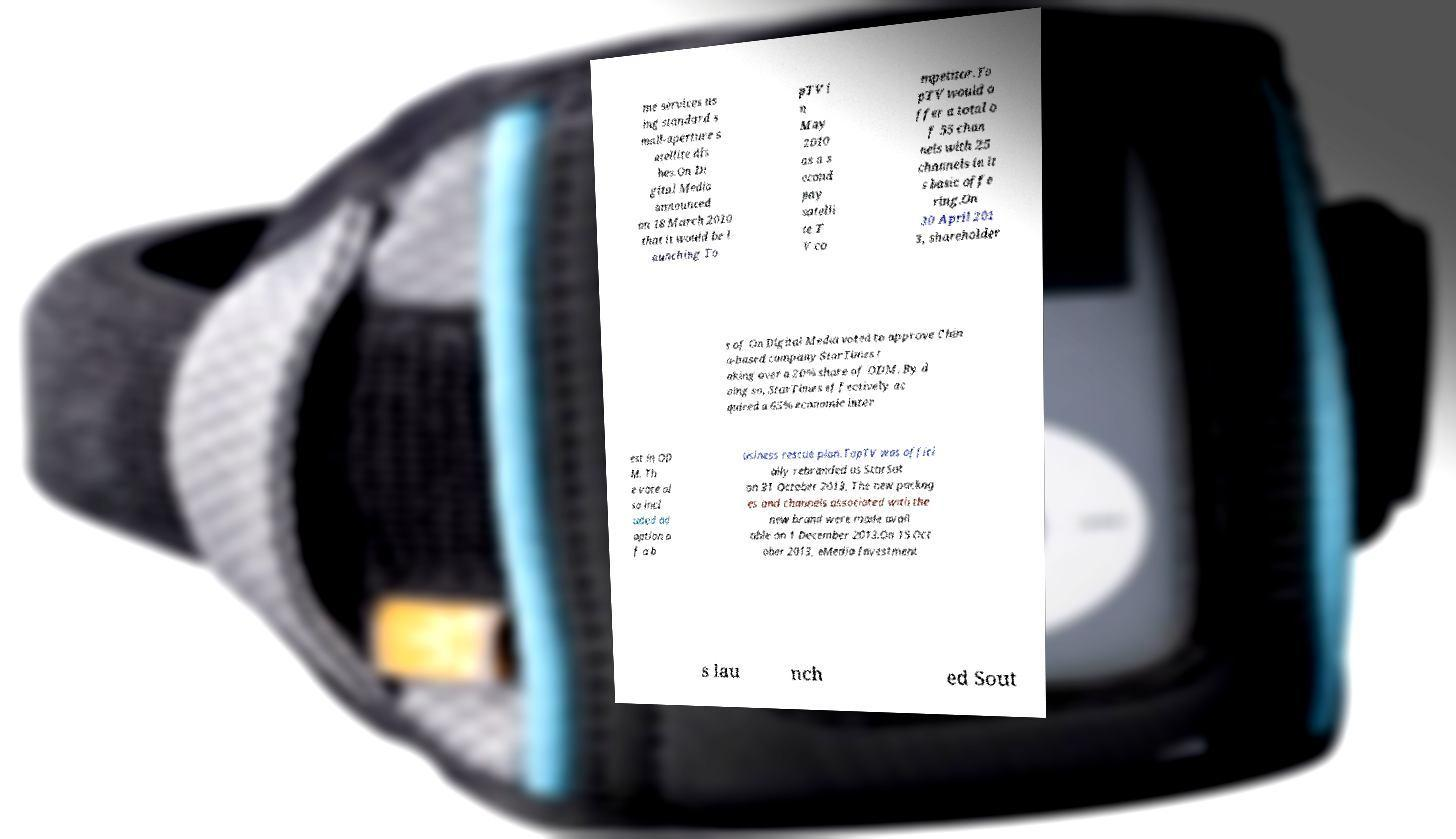Can you read and provide the text displayed in the image?This photo seems to have some interesting text. Can you extract and type it out for me? me services us ing standard s mall-aperture s atellite dis hes.On Di gital Media announced on 18 March 2010 that it would be l aunching To pTV i n May 2010 as a s econd pay satelli te T V co mpetitor.To pTV would o ffer a total o f 55 chan nels with 25 channels in it s basic offe ring.On 30 April 201 3, shareholder s of On Digital Media voted to approve Chin a-based company StarTimes t aking over a 20% share of ODM. By d oing so, StarTimes effectively ac quired a 65% economic inter est in OD M. Th e vote al so incl uded ad option o f a b usiness rescue plan.TopTV was offici ally rebranded as StarSat on 31 October 2013. The new packag es and channels associated with the new brand were made avail able on 1 December 2013.On 15 Oct ober 2013, eMedia Investment s lau nch ed Sout 